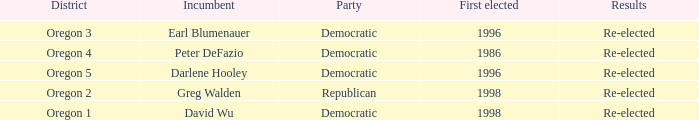Which Democratic incumbent was first elected in 1998? David Wu. 